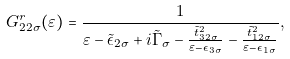<formula> <loc_0><loc_0><loc_500><loc_500>G ^ { r } _ { 2 2 \sigma } ( \varepsilon ) = \frac { 1 } { \varepsilon - \tilde { \epsilon } _ { 2 \sigma } + i \tilde { \Gamma } _ { \sigma } - \frac { \tilde { t } _ { 3 2 \sigma } ^ { 2 } } { \varepsilon - \epsilon _ { 3 \sigma } } - \frac { \tilde { t } _ { 1 2 \sigma } ^ { 2 } } { \varepsilon - \epsilon _ { 1 \sigma } } } ,</formula> 